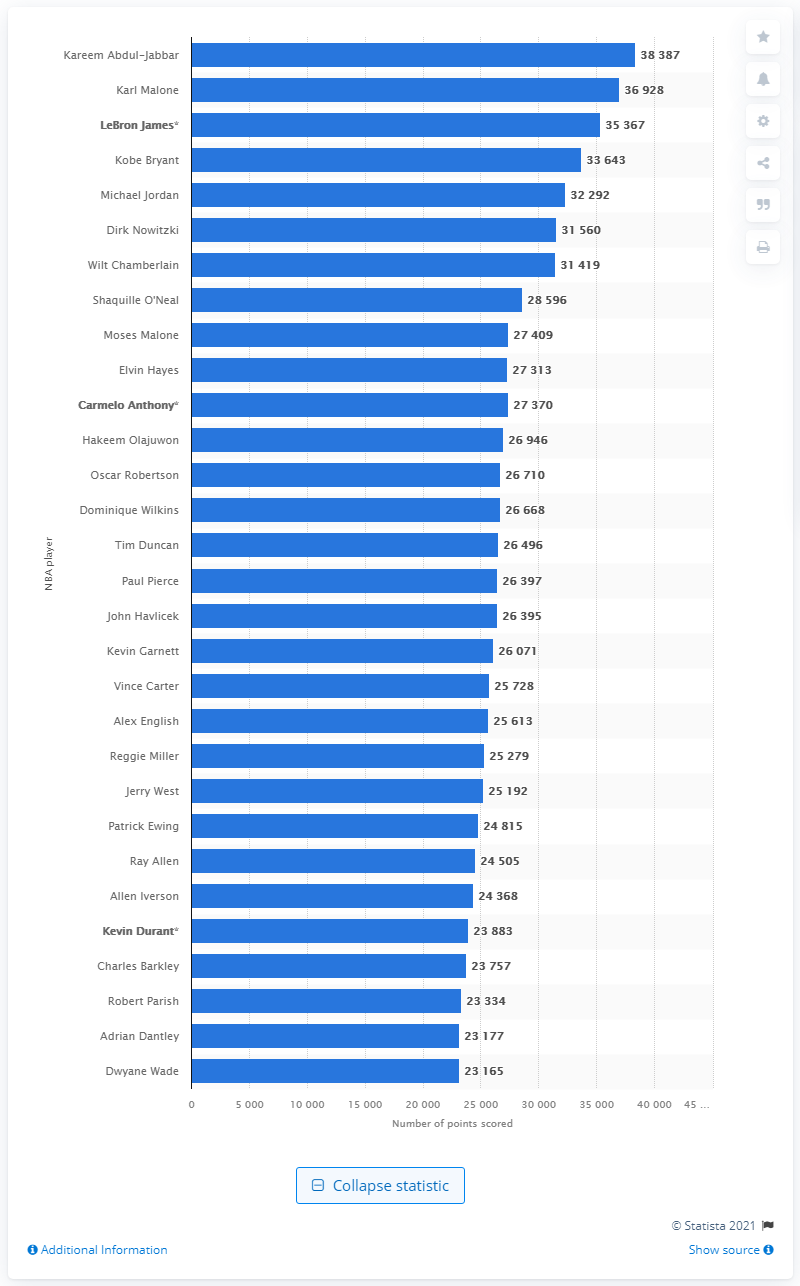Mention a couple of crucial points in this snapshot. With a record-breaking total of points, Kareem Abdul-Jabbar is currently the all-time leading scorer in the National Basketball Association. 